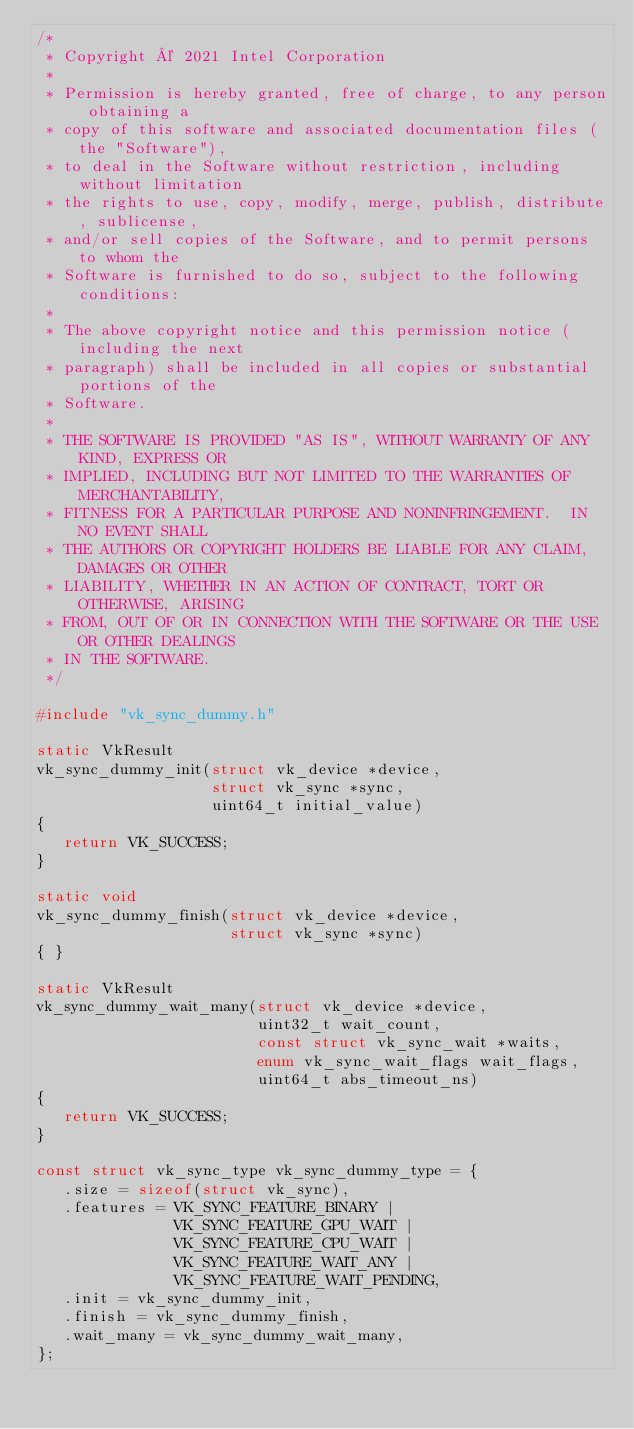<code> <loc_0><loc_0><loc_500><loc_500><_C_>/*
 * Copyright © 2021 Intel Corporation
 *
 * Permission is hereby granted, free of charge, to any person obtaining a
 * copy of this software and associated documentation files (the "Software"),
 * to deal in the Software without restriction, including without limitation
 * the rights to use, copy, modify, merge, publish, distribute, sublicense,
 * and/or sell copies of the Software, and to permit persons to whom the
 * Software is furnished to do so, subject to the following conditions:
 *
 * The above copyright notice and this permission notice (including the next
 * paragraph) shall be included in all copies or substantial portions of the
 * Software.
 *
 * THE SOFTWARE IS PROVIDED "AS IS", WITHOUT WARRANTY OF ANY KIND, EXPRESS OR
 * IMPLIED, INCLUDING BUT NOT LIMITED TO THE WARRANTIES OF MERCHANTABILITY,
 * FITNESS FOR A PARTICULAR PURPOSE AND NONINFRINGEMENT.  IN NO EVENT SHALL
 * THE AUTHORS OR COPYRIGHT HOLDERS BE LIABLE FOR ANY CLAIM, DAMAGES OR OTHER
 * LIABILITY, WHETHER IN AN ACTION OF CONTRACT, TORT OR OTHERWISE, ARISING
 * FROM, OUT OF OR IN CONNECTION WITH THE SOFTWARE OR THE USE OR OTHER DEALINGS
 * IN THE SOFTWARE.
 */

#include "vk_sync_dummy.h"

static VkResult
vk_sync_dummy_init(struct vk_device *device,
                   struct vk_sync *sync,
                   uint64_t initial_value)
{
   return VK_SUCCESS;
}

static void
vk_sync_dummy_finish(struct vk_device *device,
                     struct vk_sync *sync)
{ }

static VkResult
vk_sync_dummy_wait_many(struct vk_device *device,
                        uint32_t wait_count,
                        const struct vk_sync_wait *waits,
                        enum vk_sync_wait_flags wait_flags,
                        uint64_t abs_timeout_ns)
{
   return VK_SUCCESS;
}

const struct vk_sync_type vk_sync_dummy_type = {
   .size = sizeof(struct vk_sync),
   .features = VK_SYNC_FEATURE_BINARY |
               VK_SYNC_FEATURE_GPU_WAIT |
               VK_SYNC_FEATURE_CPU_WAIT |
               VK_SYNC_FEATURE_WAIT_ANY |
               VK_SYNC_FEATURE_WAIT_PENDING,
   .init = vk_sync_dummy_init,
   .finish = vk_sync_dummy_finish,
   .wait_many = vk_sync_dummy_wait_many,
};
</code> 